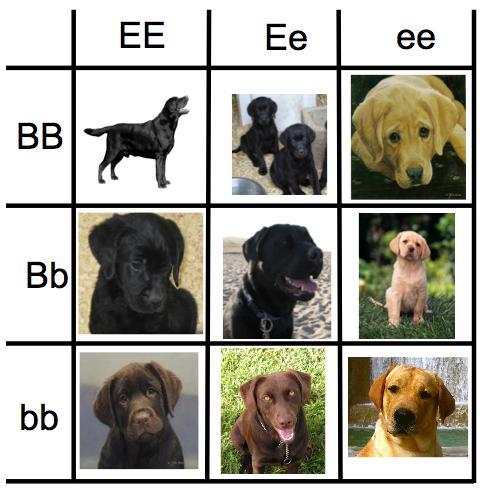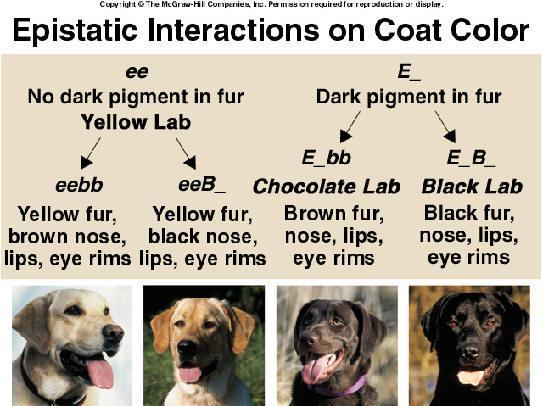The first image is the image on the left, the second image is the image on the right. Assess this claim about the two images: "One dog in the left image has its tongue out.". Correct or not? Answer yes or no. Yes. 